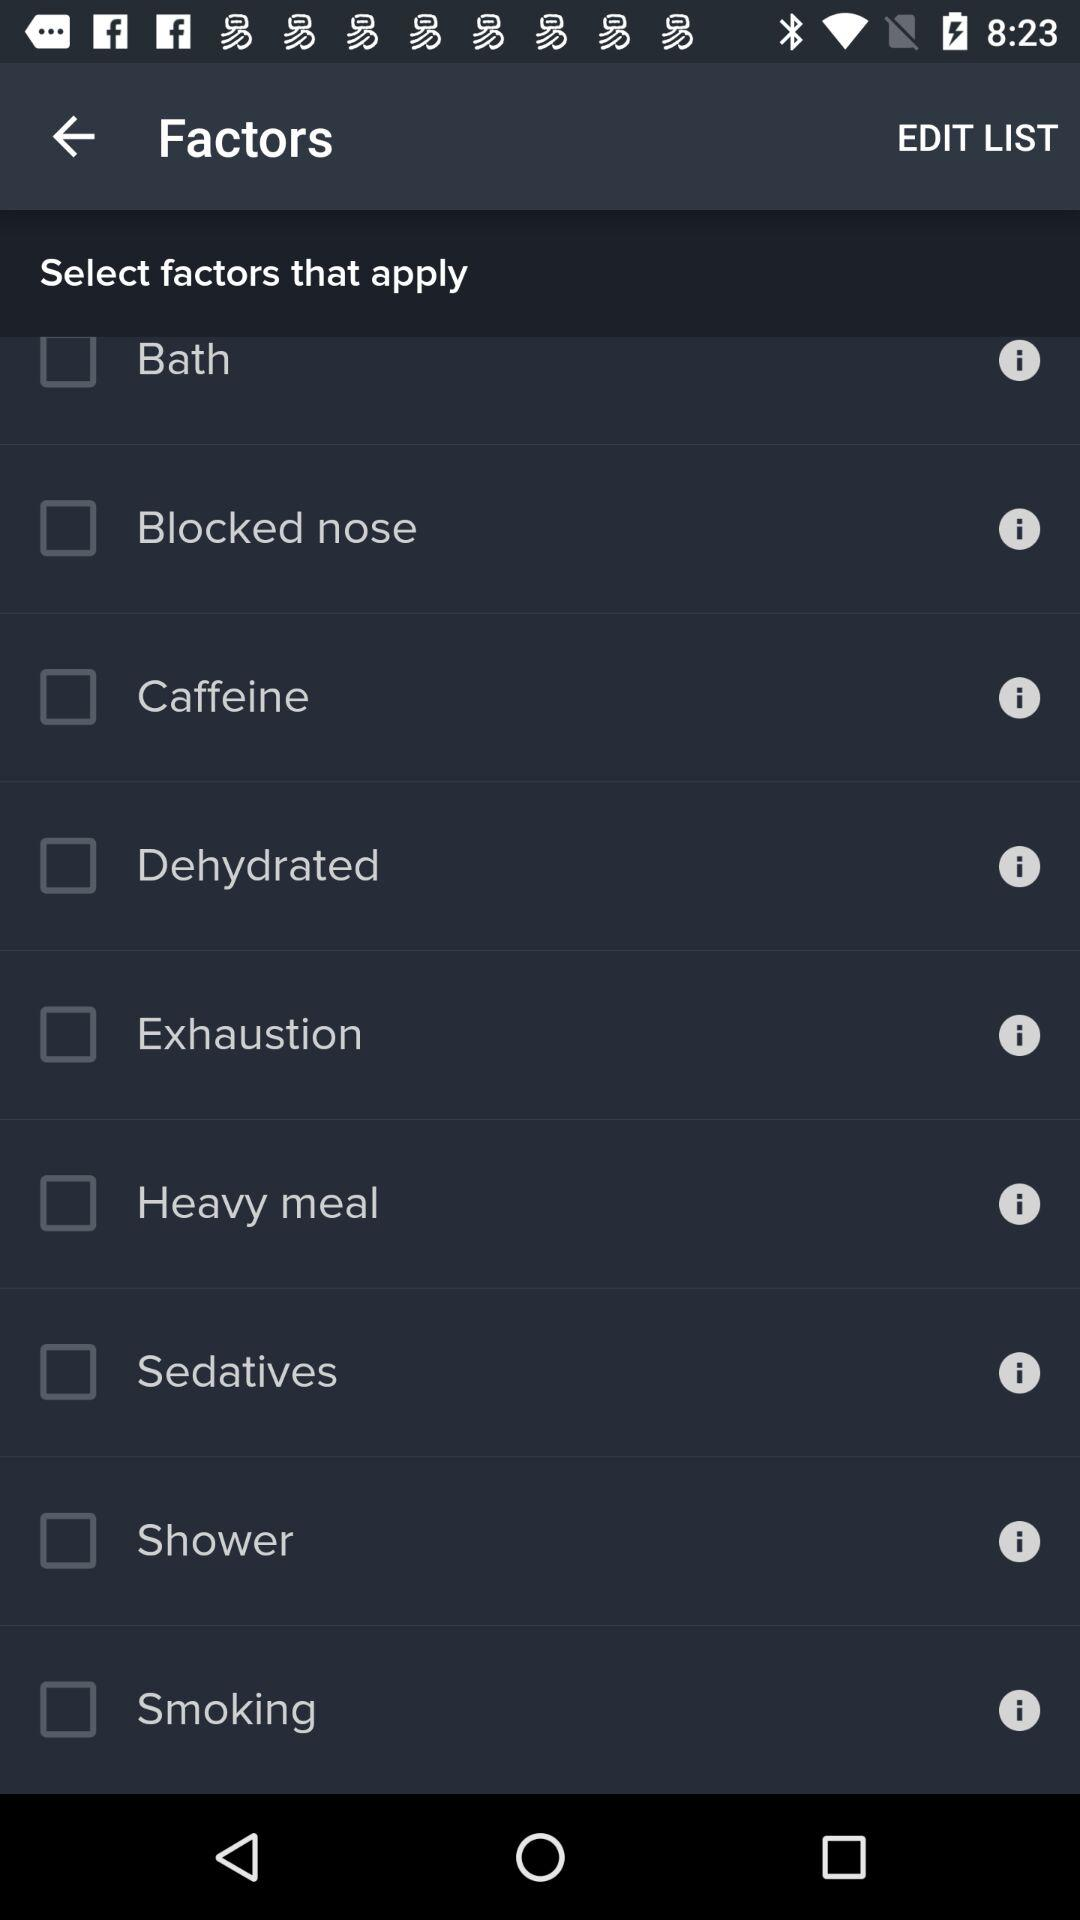Is "Smoking" selected or not?
Answer the question using a single word or phrase. It's "Not selected". 